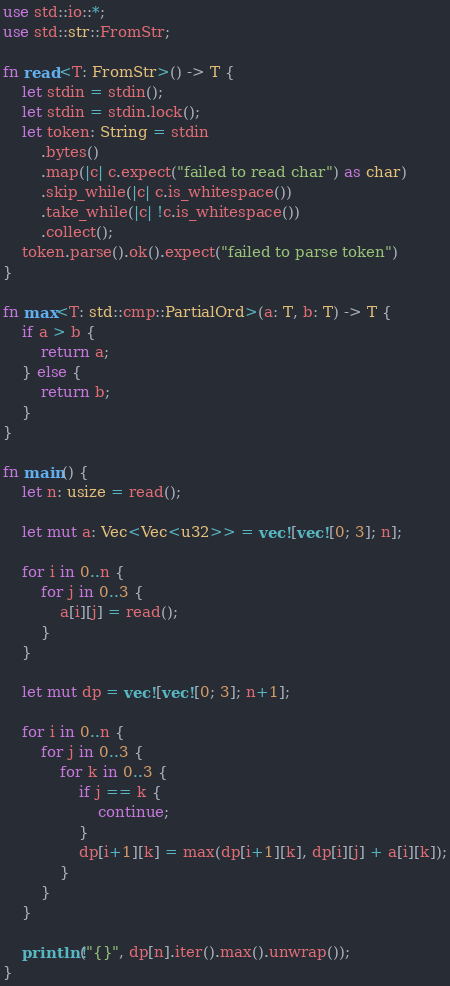Convert code to text. <code><loc_0><loc_0><loc_500><loc_500><_Rust_>use std::io::*;
use std::str::FromStr;

fn read<T: FromStr>() -> T {
    let stdin = stdin();
    let stdin = stdin.lock();
    let token: String = stdin
        .bytes()
        .map(|c| c.expect("failed to read char") as char) 
        .skip_while(|c| c.is_whitespace())
        .take_while(|c| !c.is_whitespace())
        .collect();
    token.parse().ok().expect("failed to parse token")
}

fn max<T: std::cmp::PartialOrd>(a: T, b: T) -> T {
    if a > b {
        return a;
    } else {
        return b;
    }
}

fn main() {
    let n: usize = read();

    let mut a: Vec<Vec<u32>> = vec![vec![0; 3]; n];

    for i in 0..n {
        for j in 0..3 {
            a[i][j] = read();
        }
    }

    let mut dp = vec![vec![0; 3]; n+1];

    for i in 0..n {
        for j in 0..3 {
            for k in 0..3 {
                if j == k {
                    continue;
                }
                dp[i+1][k] = max(dp[i+1][k], dp[i][j] + a[i][k]);
            }
        }
    }

    println!("{}", dp[n].iter().max().unwrap());
}
</code> 